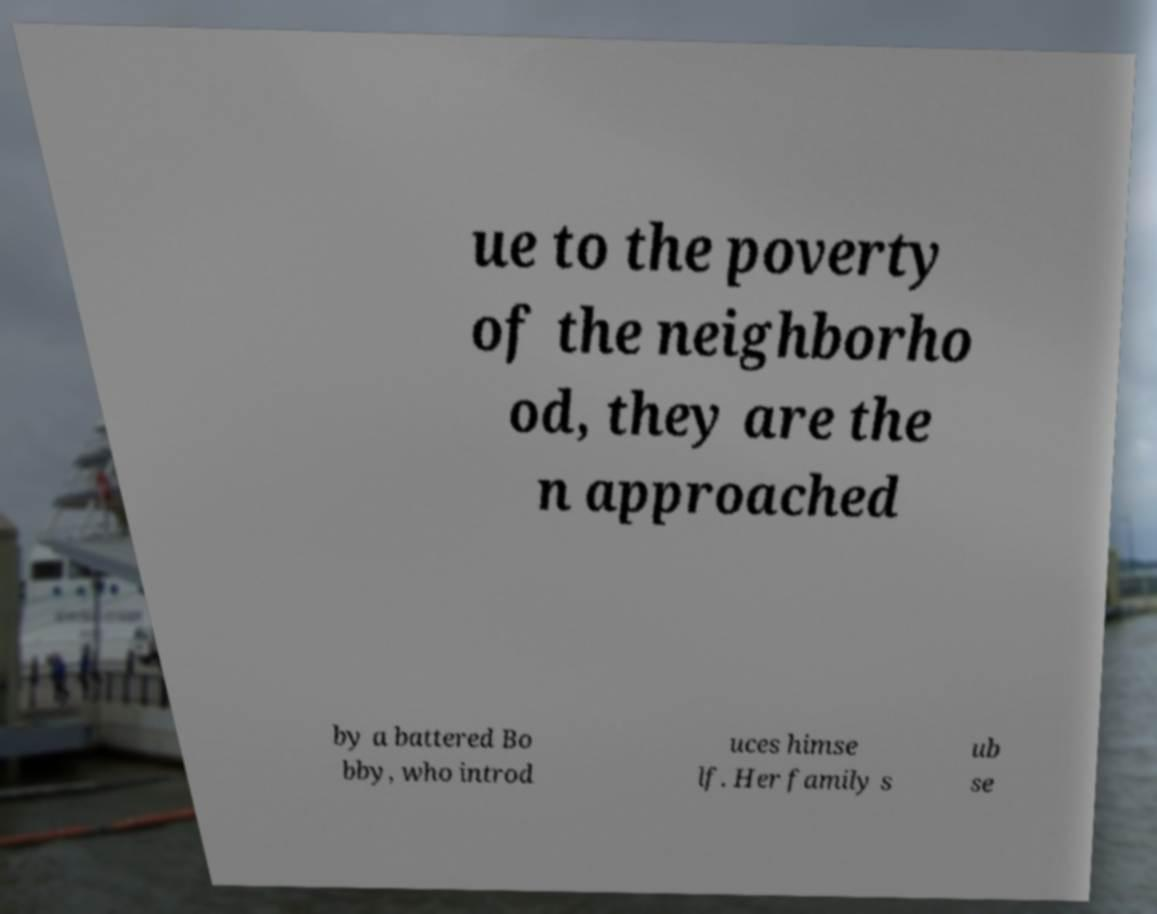I need the written content from this picture converted into text. Can you do that? ue to the poverty of the neighborho od, they are the n approached by a battered Bo bby, who introd uces himse lf. Her family s ub se 